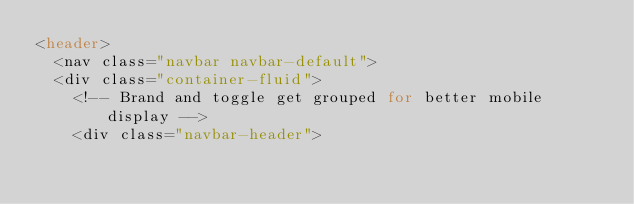<code> <loc_0><loc_0><loc_500><loc_500><_PHP_><header>
	<nav class="navbar navbar-default">
  <div class="container-fluid">
    <!-- Brand and toggle get grouped for better mobile display -->
    <div class="navbar-header"></code> 